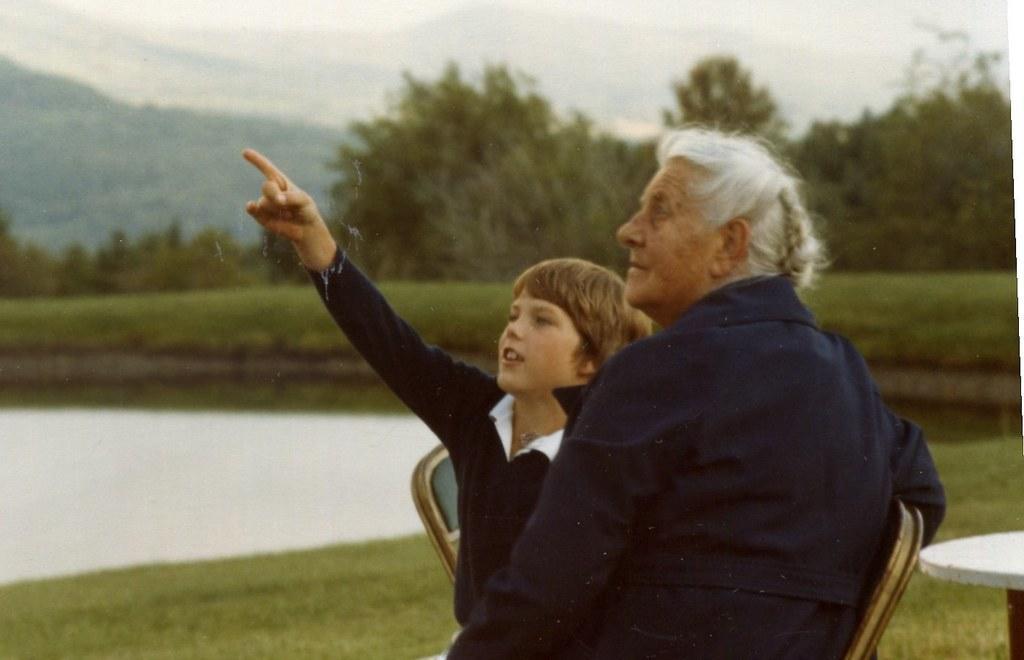Can you describe this image briefly? This 2 persons are highlighted in this picture. This 2 persons are sitting on a chair. Far there are number of trees. This is a freshwater river. Grass is in green color. Backside of this person there is a table. 